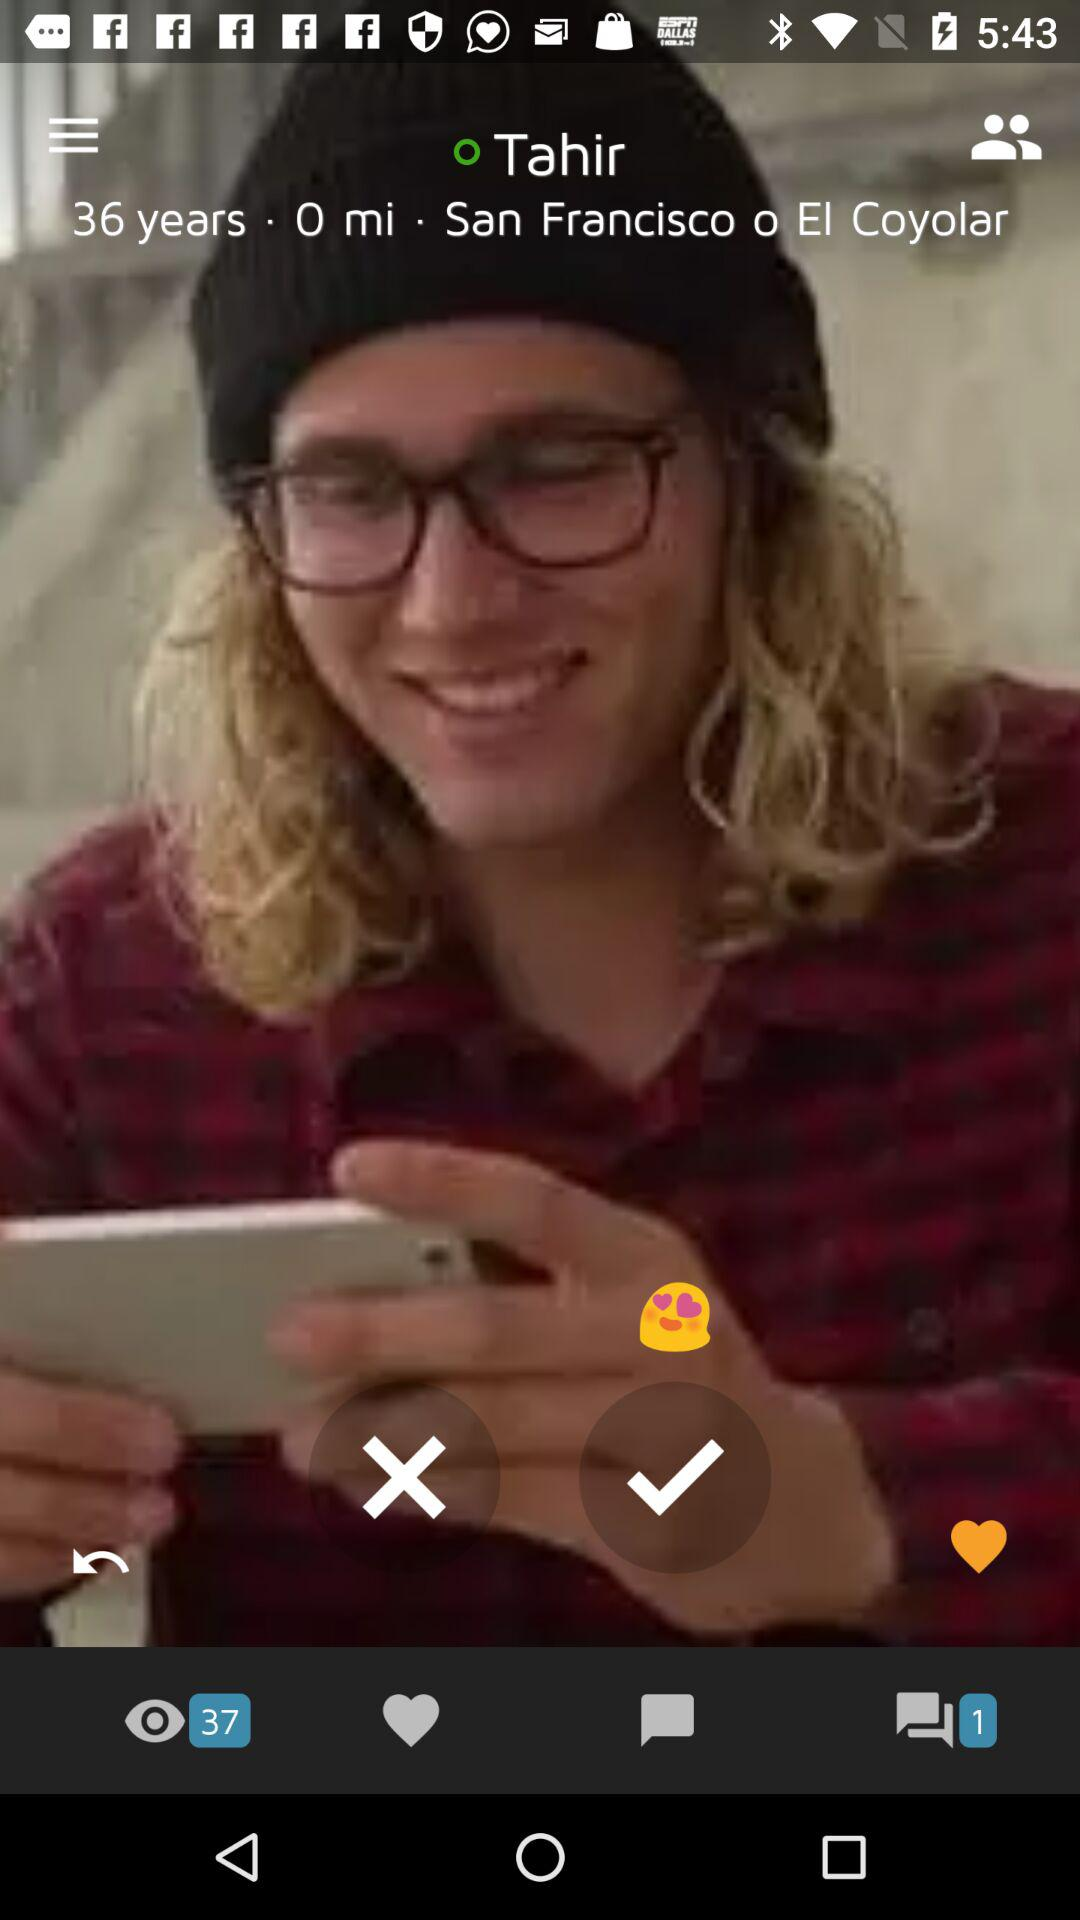How many messages are there in the chat box? There is only 1 message in the chat box. 